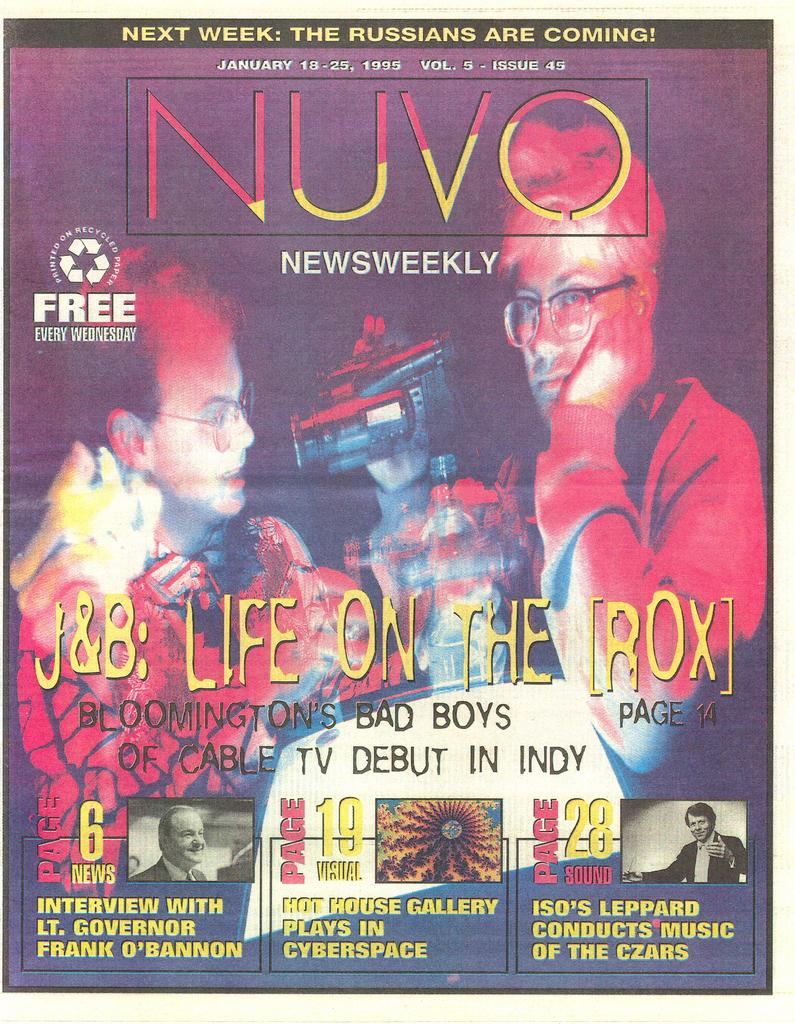What is featured in the image? There is a poster in the image. What can be seen on the poster? The poster contains two persons and a camera. Are there any words on the poster? Yes, there is text in the poster. What type of stick can be seen in the hands of the persons on the poster? There is no stick present in the image or on the poster. 